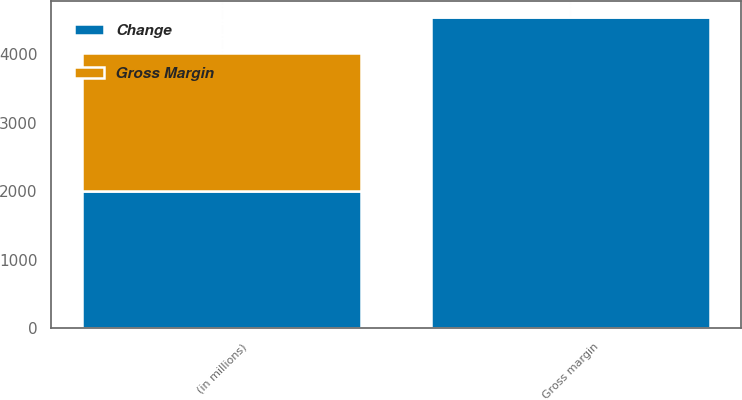<chart> <loc_0><loc_0><loc_500><loc_500><stacked_bar_chart><ecel><fcel>(in millions)<fcel>Gross margin<nl><fcel>Gross Margin<fcel>2012<fcel>9<nl><fcel>Change<fcel>2012<fcel>4541<nl></chart> 